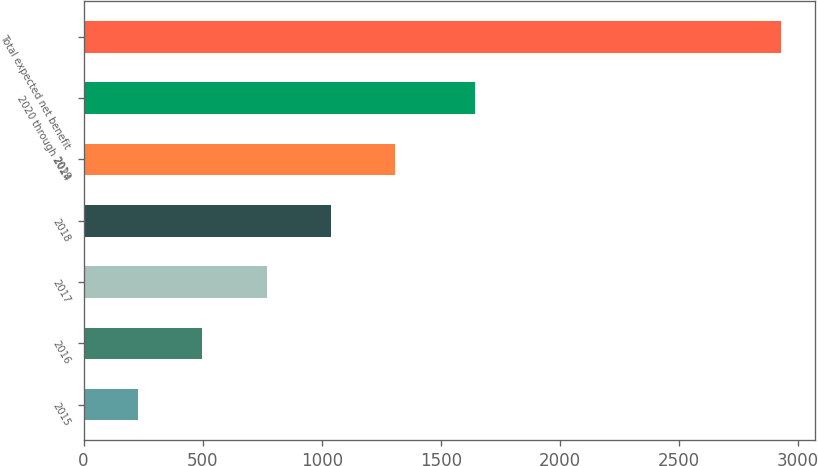<chart> <loc_0><loc_0><loc_500><loc_500><bar_chart><fcel>2015<fcel>2016<fcel>2017<fcel>2018<fcel>2019<fcel>2020 through 2024<fcel>Total expected net benefit<nl><fcel>229<fcel>498.8<fcel>768.6<fcel>1038.4<fcel>1308.2<fcel>1643<fcel>2927<nl></chart> 